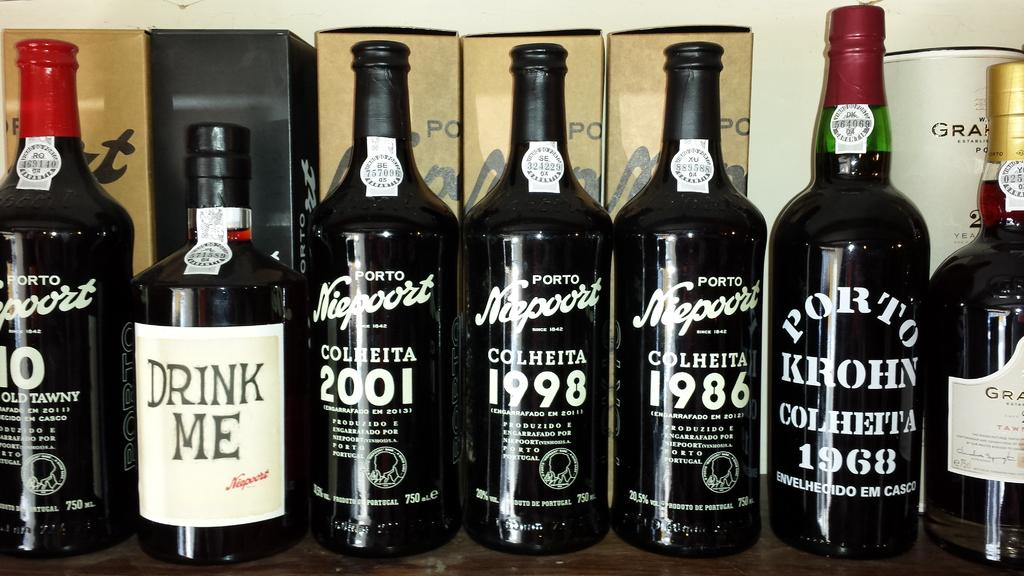Provide a one-sentence caption for the provided image. Bottles of liquor with white lettering and one reads "Drink Me". 